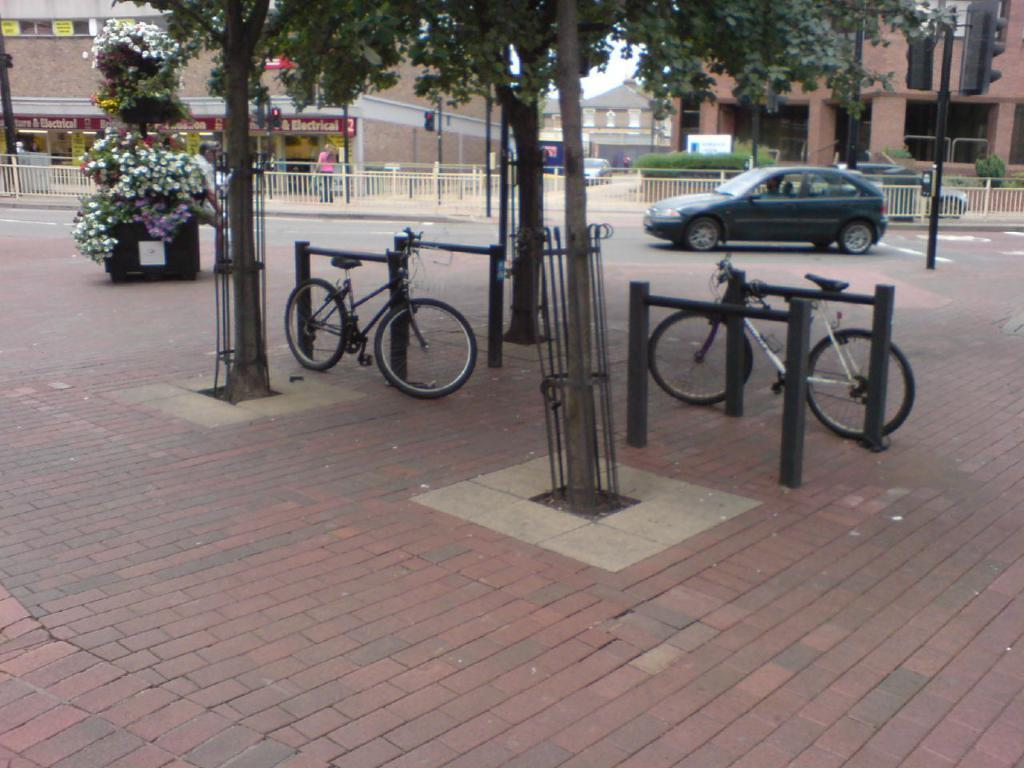What type of vehicles are in the image? There are bicycles in the image. What natural elements can be seen in the image? There are trees in the image. What man-made structure is present in the image? There is a fence in the image. What mode of transportation can be seen in the image besides bicycles? There is a car in the image. What type of buildings are visible in the image? There are buildings in the image. How many brothers are depicted in the image? There are no brothers present in the image. What type of art can be seen on the buildings in the image? There is no art visible on the buildings in the image. 